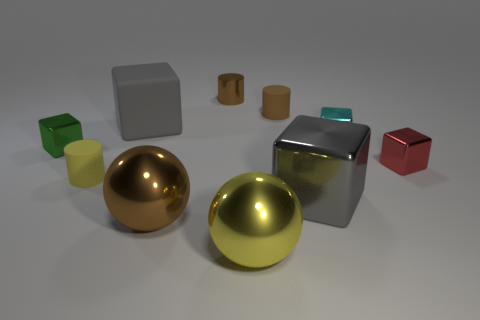Do the big matte cube and the large metal cube have the same color?
Give a very brief answer. Yes. What number of large metal things are both right of the tiny brown rubber object and on the left side of the large metal block?
Your response must be concise. 0. How many other big brown objects are the same shape as the brown rubber thing?
Your response must be concise. 0. Are the tiny green object and the small yellow thing made of the same material?
Provide a succinct answer. No. What shape is the metallic object that is behind the small rubber thing behind the large matte block?
Keep it short and to the point. Cylinder. How many matte cubes are behind the big gray thing that is behind the cyan object?
Offer a terse response. 0. What is the material of the big thing that is behind the brown metallic ball and in front of the tiny yellow thing?
Offer a very short reply. Metal. What is the shape of the green object that is the same size as the metal cylinder?
Ensure brevity in your answer.  Cube. The small matte cylinder that is behind the shiny cube that is to the left of the yellow matte cylinder on the right side of the green metallic cube is what color?
Your answer should be very brief. Brown. How many objects are either things that are behind the gray rubber object or tiny metallic cylinders?
Provide a short and direct response. 2. 